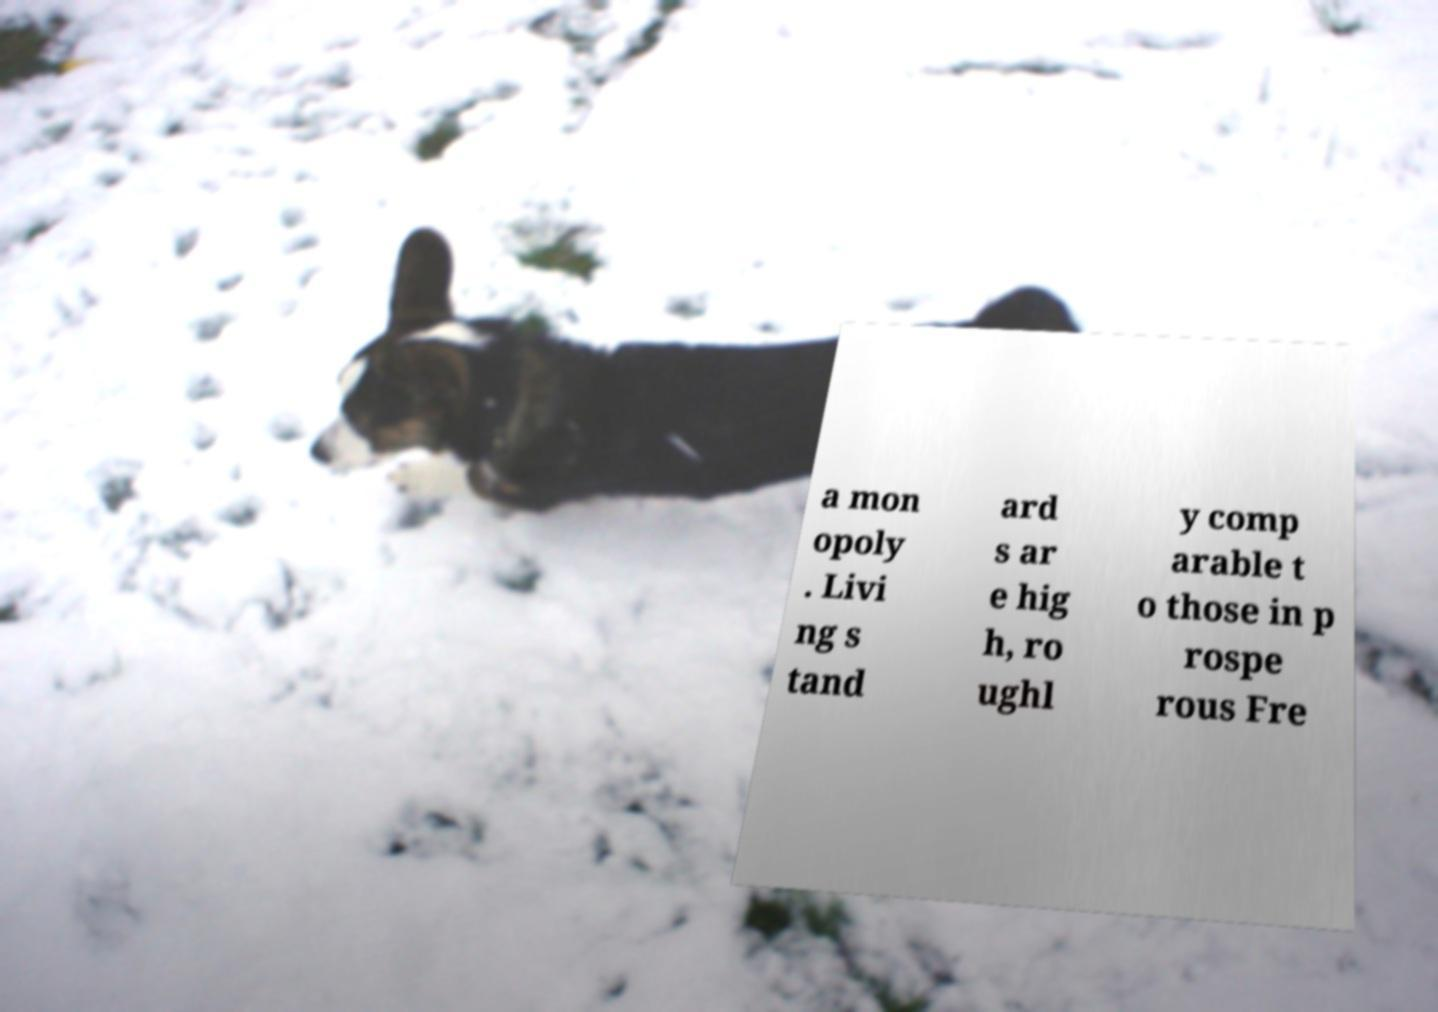Could you assist in decoding the text presented in this image and type it out clearly? a mon opoly . Livi ng s tand ard s ar e hig h, ro ughl y comp arable t o those in p rospe rous Fre 